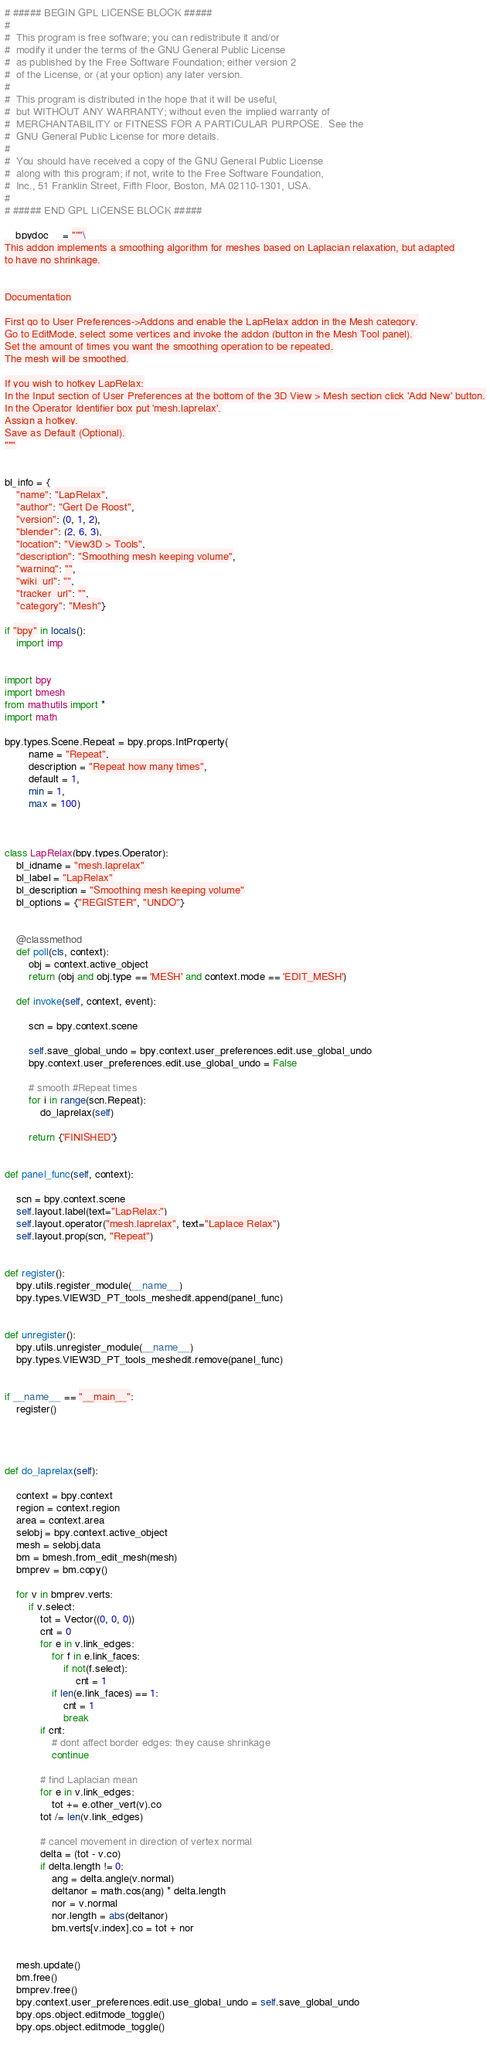Convert code to text. <code><loc_0><loc_0><loc_500><loc_500><_Python_># ##### BEGIN GPL LICENSE BLOCK #####
#
#  This program is free software; you can redistribute it and/or
#  modify it under the terms of the GNU General Public License
#  as published by the Free Software Foundation; either version 2
#  of the License, or (at your option) any later version.
#
#  This program is distributed in the hope that it will be useful,
#  but WITHOUT ANY WARRANTY; without even the implied warranty of
#  MERCHANTABILITY or FITNESS FOR A PARTICULAR PURPOSE.  See the
#  GNU General Public License for more details.
#
#  You should have received a copy of the GNU General Public License
#  along with this program; if not, write to the Free Software Foundation,
#  Inc., 51 Franklin Street, Fifth Floor, Boston, MA 02110-1301, USA.
#
# ##### END GPL LICENSE BLOCK #####

__bpydoc__ = """\
This addon implements a smoothing algorithm for meshes based on Laplacian relaxation, but adapted
to have no shrinkage.


Documentation

First go to User Preferences->Addons and enable the LapRelax addon in the Mesh category.
Go to EditMode, select some vertices and invoke the addon (button in the Mesh Tool panel).
Set the amount of times you want the smoothing operation to be repeated.
The mesh will be smoothed.

If you wish to hotkey LapRelax:
In the Input section of User Preferences at the bottom of the 3D View > Mesh section click 'Add New' button.
In the Operator Identifier box put 'mesh.laprelax'.
Assign a hotkey.
Save as Default (Optional).
"""


bl_info = {
	"name": "LapRelax",
	"author": "Gert De Roost",
	"version": (0, 1, 2),
	"blender": (2, 6, 3),
	"location": "View3D > Tools",
	"description": "Smoothing mesh keeping volume",
	"warning": "",
	"wiki_url": "",
	"tracker_url": "",
	"category": "Mesh"}

if "bpy" in locals():
    import imp


import bpy
import bmesh
from mathutils import *
import math

bpy.types.Scene.Repeat = bpy.props.IntProperty(
		name = "Repeat", 
		description = "Repeat how many times",
		default = 1,
		min = 1,
		max = 100)



class LapRelax(bpy.types.Operator):
	bl_idname = "mesh.laprelax"
	bl_label = "LapRelax"
	bl_description = "Smoothing mesh keeping volume"
	bl_options = {"REGISTER", "UNDO"}
	

	@classmethod
	def poll(cls, context):
		obj = context.active_object
		return (obj and obj.type == 'MESH' and context.mode == 'EDIT_MESH')

	def invoke(self, context, event):
		
		scn = bpy.context.scene
		
		self.save_global_undo = bpy.context.user_preferences.edit.use_global_undo
		bpy.context.user_preferences.edit.use_global_undo = False
		
		# smooth #Repeat times
		for i in range(scn.Repeat):
			do_laprelax(self)
		
		return {'FINISHED'}


def panel_func(self, context):
	
	scn = bpy.context.scene
	self.layout.label(text="LapRelax:")
	self.layout.operator("mesh.laprelax", text="Laplace Relax")
	self.layout.prop(scn, "Repeat")


def register():
	bpy.utils.register_module(__name__)
	bpy.types.VIEW3D_PT_tools_meshedit.append(panel_func)


def unregister():
	bpy.utils.unregister_module(__name__)
	bpy.types.VIEW3D_PT_tools_meshedit.remove(panel_func)


if __name__ == "__main__":
	register()




def do_laprelax(self):

	context = bpy.context
	region = context.region  
	area = context.area
	selobj = bpy.context.active_object
	mesh = selobj.data
	bm = bmesh.from_edit_mesh(mesh)
	bmprev = bm.copy()

	for v in bmprev.verts:
		if v.select:
			tot = Vector((0, 0, 0))
			cnt = 0
			for e in v.link_edges:
				for f in e.link_faces:
					if not(f.select):
						cnt = 1
				if len(e.link_faces) == 1:
					cnt = 1
					break
			if cnt:
				# dont affect border edges: they cause shrinkage
				continue
				
			# find Laplacian mean
			for e in v.link_edges:
				tot += e.other_vert(v).co
			tot /= len(v.link_edges)
			
			# cancel movement in direction of vertex normal
			delta = (tot - v.co)
			if delta.length != 0:
				ang = delta.angle(v.normal)
				deltanor = math.cos(ang) * delta.length
				nor = v.normal
				nor.length = abs(deltanor)
				bm.verts[v.index].co = tot + nor
		
		
	mesh.update()
	bm.free()
	bmprev.free()
	bpy.context.user_preferences.edit.use_global_undo = self.save_global_undo
	bpy.ops.object.editmode_toggle()
	bpy.ops.object.editmode_toggle()
	
</code> 